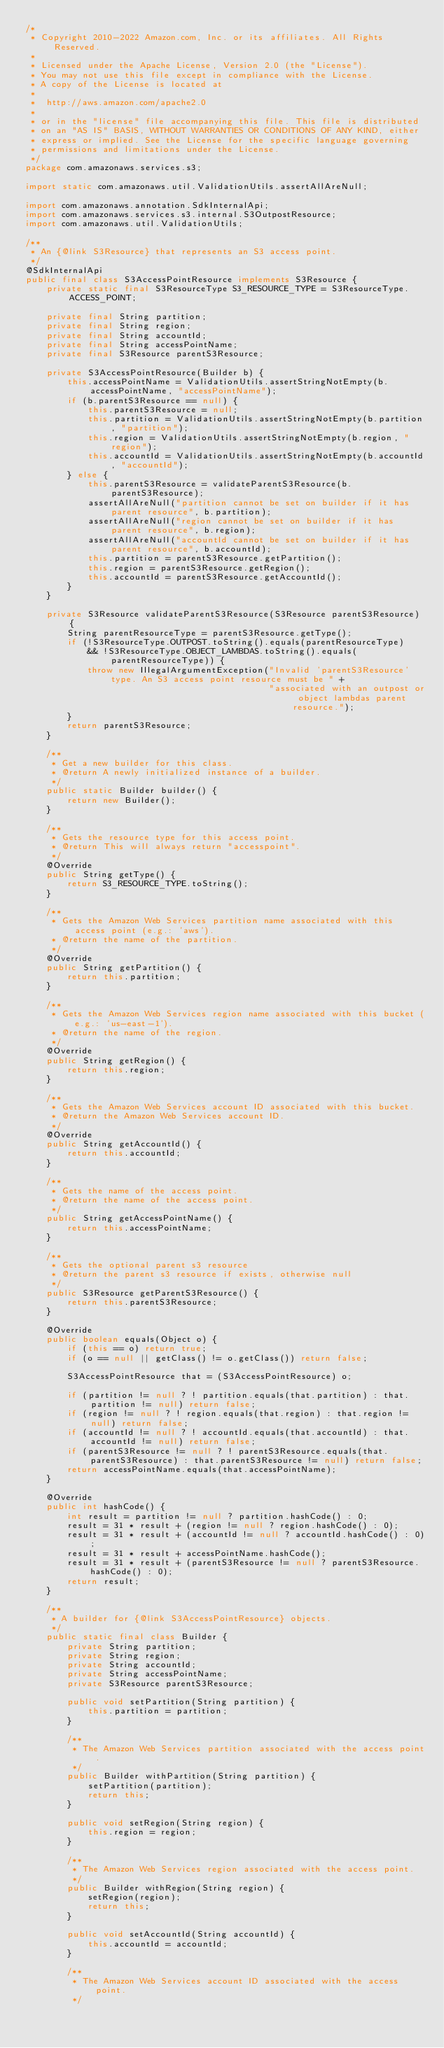Convert code to text. <code><loc_0><loc_0><loc_500><loc_500><_Java_>/*
 * Copyright 2010-2022 Amazon.com, Inc. or its affiliates. All Rights Reserved.
 *
 * Licensed under the Apache License, Version 2.0 (the "License").
 * You may not use this file except in compliance with the License.
 * A copy of the License is located at
 *
 *  http://aws.amazon.com/apache2.0
 *
 * or in the "license" file accompanying this file. This file is distributed
 * on an "AS IS" BASIS, WITHOUT WARRANTIES OR CONDITIONS OF ANY KIND, either
 * express or implied. See the License for the specific language governing
 * permissions and limitations under the License.
 */
package com.amazonaws.services.s3;

import static com.amazonaws.util.ValidationUtils.assertAllAreNull;

import com.amazonaws.annotation.SdkInternalApi;
import com.amazonaws.services.s3.internal.S3OutpostResource;
import com.amazonaws.util.ValidationUtils;

/**
 * An {@link S3Resource} that represents an S3 access point.
 */
@SdkInternalApi
public final class S3AccessPointResource implements S3Resource {
    private static final S3ResourceType S3_RESOURCE_TYPE = S3ResourceType.ACCESS_POINT;

    private final String partition;
    private final String region;
    private final String accountId;
    private final String accessPointName;
    private final S3Resource parentS3Resource;

    private S3AccessPointResource(Builder b) {
        this.accessPointName = ValidationUtils.assertStringNotEmpty(b.accessPointName, "accessPointName");
        if (b.parentS3Resource == null) {
            this.parentS3Resource = null;
            this.partition = ValidationUtils.assertStringNotEmpty(b.partition, "partition");
            this.region = ValidationUtils.assertStringNotEmpty(b.region, "region");
            this.accountId = ValidationUtils.assertStringNotEmpty(b.accountId, "accountId");
        } else {
            this.parentS3Resource = validateParentS3Resource(b.parentS3Resource);
            assertAllAreNull("partition cannot be set on builder if it has parent resource", b.partition);
            assertAllAreNull("region cannot be set on builder if it has parent resource", b.region);
            assertAllAreNull("accountId cannot be set on builder if it has parent resource", b.accountId);
            this.partition = parentS3Resource.getPartition();
            this.region = parentS3Resource.getRegion();
            this.accountId = parentS3Resource.getAccountId();
        }
    }

    private S3Resource validateParentS3Resource(S3Resource parentS3Resource) {
        String parentResourceType = parentS3Resource.getType();
        if (!S3ResourceType.OUTPOST.toString().equals(parentResourceType)
            && !S3ResourceType.OBJECT_LAMBDAS.toString().equals(parentResourceType)) {
            throw new IllegalArgumentException("Invalid 'parentS3Resource' type. An S3 access point resource must be " +
                                               "associated with an outpost or object lambdas parent resource.");
        }
        return parentS3Resource;
    }

    /**
     * Get a new builder for this class.
     * @return A newly initialized instance of a builder.
     */
    public static Builder builder() {
        return new Builder();
    }

    /**
     * Gets the resource type for this access point.
     * @return This will always return "accesspoint".
     */
    @Override
    public String getType() {
        return S3_RESOURCE_TYPE.toString();
    }

    /**
     * Gets the Amazon Web Services partition name associated with this access point (e.g.: 'aws').
     * @return the name of the partition.
     */
    @Override
    public String getPartition() {
        return this.partition;
    }

    /**
     * Gets the Amazon Web Services region name associated with this bucket (e.g.: 'us-east-1').
     * @return the name of the region.
     */
    @Override
    public String getRegion() {
        return this.region;
    }

    /**
     * Gets the Amazon Web Services account ID associated with this bucket.
     * @return the Amazon Web Services account ID.
     */
    @Override
    public String getAccountId() {
        return this.accountId;
    }

    /**
     * Gets the name of the access point.
     * @return the name of the access point.
     */
    public String getAccessPointName() {
        return this.accessPointName;
    }

    /**
     * Gets the optional parent s3 resource
     * @return the parent s3 resource if exists, otherwise null
     */
    public S3Resource getParentS3Resource() {
        return this.parentS3Resource;
    }

    @Override
    public boolean equals(Object o) {
        if (this == o) return true;
        if (o == null || getClass() != o.getClass()) return false;

        S3AccessPointResource that = (S3AccessPointResource) o;

        if (partition != null ? ! partition.equals(that.partition) : that.partition != null) return false;
        if (region != null ? ! region.equals(that.region) : that.region != null) return false;
        if (accountId != null ? ! accountId.equals(that.accountId) : that.accountId != null) return false;
        if (parentS3Resource != null ? ! parentS3Resource.equals(that.parentS3Resource) : that.parentS3Resource != null) return false;
        return accessPointName.equals(that.accessPointName);
    }

    @Override
    public int hashCode() {
        int result = partition != null ? partition.hashCode() : 0;
        result = 31 * result + (region != null ? region.hashCode() : 0);
        result = 31 * result + (accountId != null ? accountId.hashCode() : 0);
        result = 31 * result + accessPointName.hashCode();
        result = 31 * result + (parentS3Resource != null ? parentS3Resource.hashCode() : 0);
        return result;
    }

    /**
     * A builder for {@link S3AccessPointResource} objects.
     */
    public static final class Builder {
        private String partition;
        private String region;
        private String accountId;
        private String accessPointName;
        private S3Resource parentS3Resource;

        public void setPartition(String partition) {
            this.partition = partition;
        }

        /**
         * The Amazon Web Services partition associated with the access point.
         */
        public Builder withPartition(String partition) {
            setPartition(partition);
            return this;
        }

        public void setRegion(String region) {
            this.region = region;
        }

        /**
         * The Amazon Web Services region associated with the access point.
         */
        public Builder withRegion(String region) {
            setRegion(region);
            return this;
        }

        public void setAccountId(String accountId) {
            this.accountId = accountId;
        }

        /**
         * The Amazon Web Services account ID associated with the access point.
         */</code> 